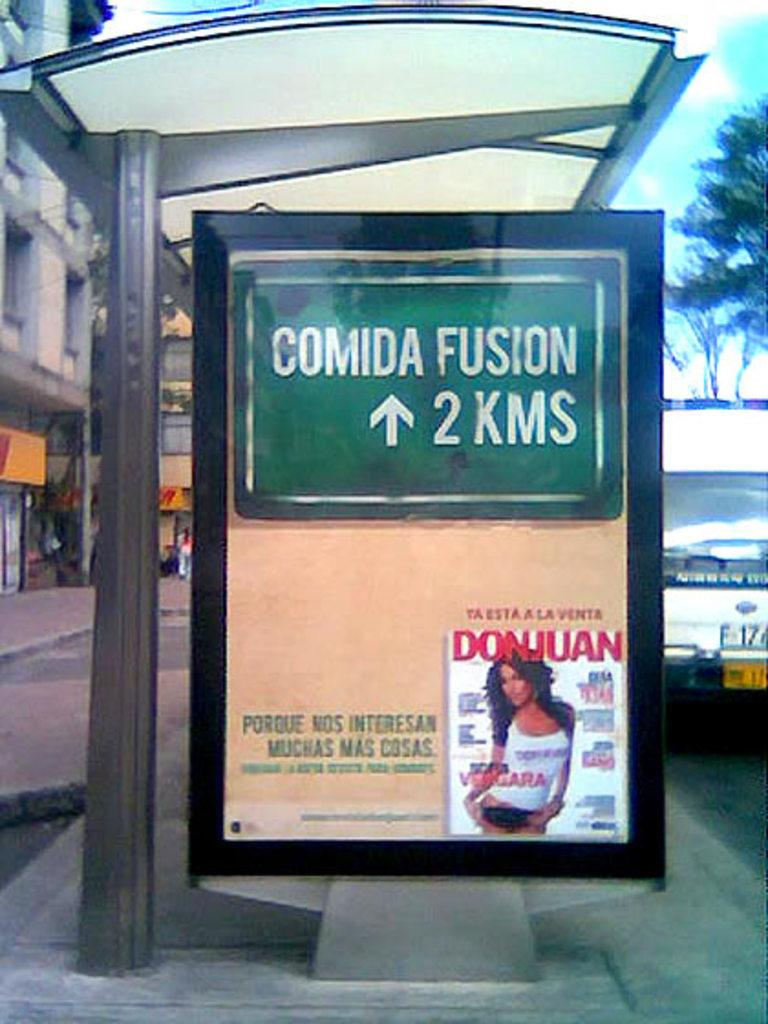<image>
Render a clear and concise summary of the photo. a poster that has the words comida fusion on it 